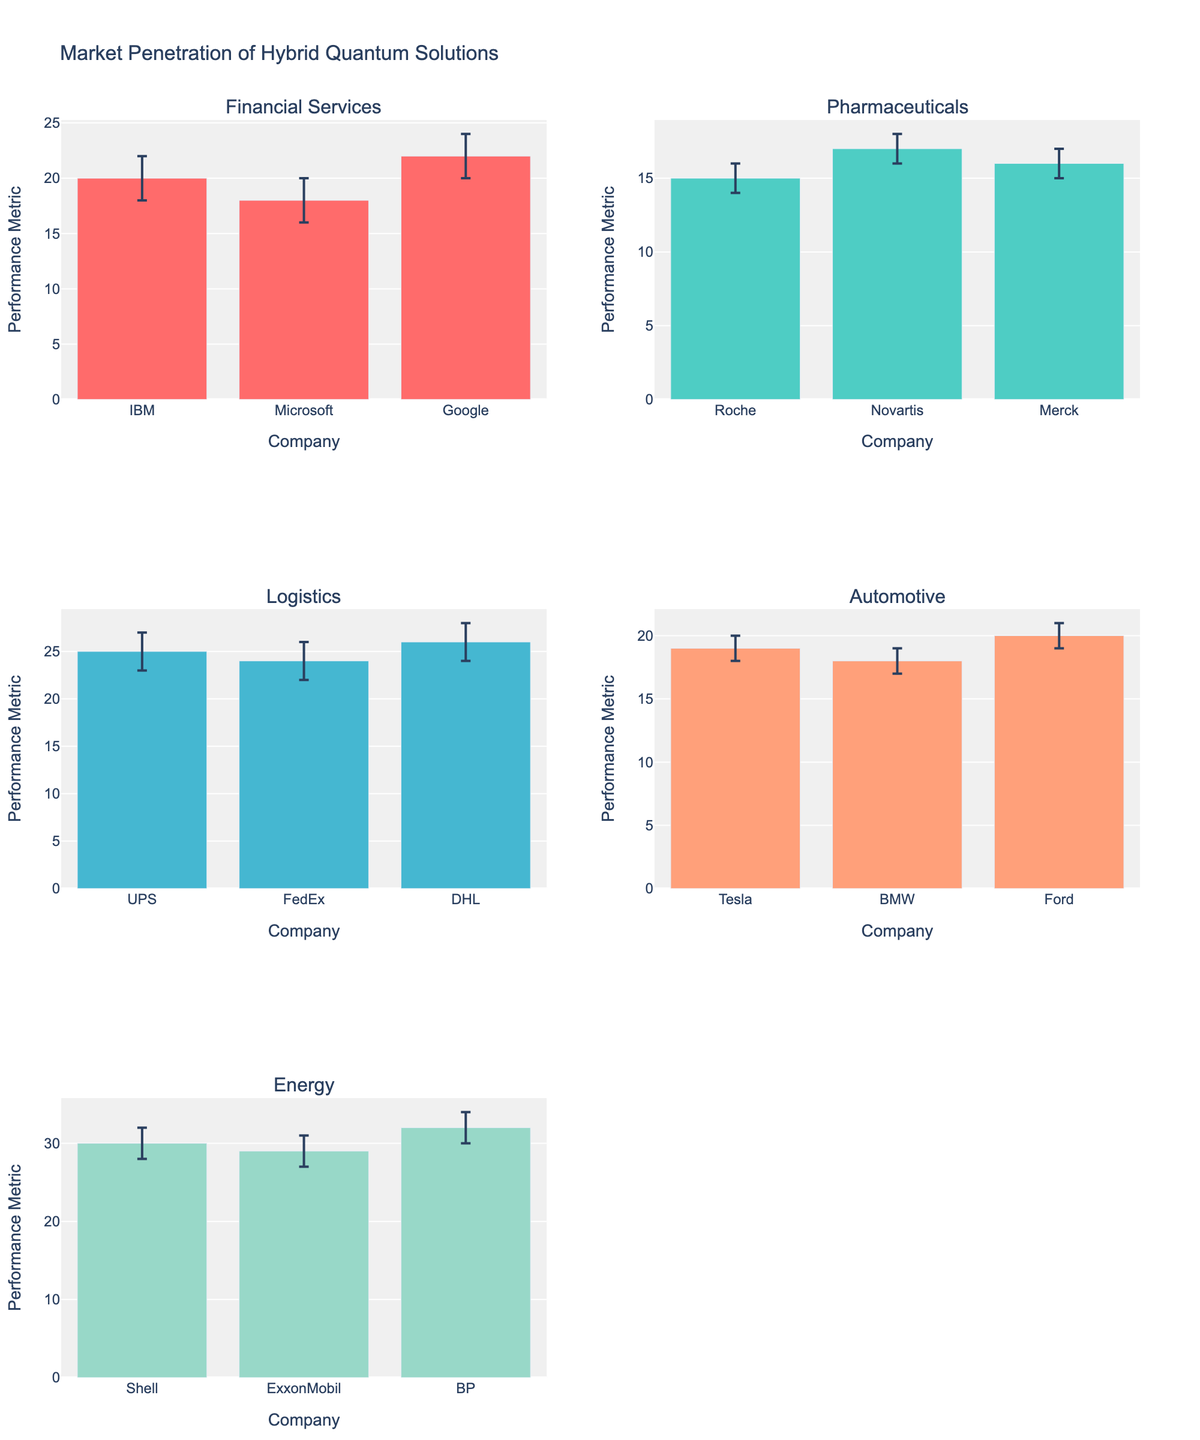how many companies are represented in the logistics segment? there are three companies listed within the logistics segment, which are ups, FedEx, and dhl.
Answer: 3 what is the difference between the highest and lowest performance metric in the financial services segment? the highest performance metric in the financial services segment is from Google at 22, and the lowest is from Microsoft at 18. the difference between the two is 22 - 18 = 4.
Answer: 4 which company in the energy segment has the largest error margin in their performance metric? to find the largest error margin, check the bounds. shell (32-28=4), exxonmobil (31-27=4), and bp (34-30=4). so exxonmobil and bp have tied for the largest error margin of 4.
Answer: bp, exxonmobil how does the performance metric of tesla compare to that of ford in the automotive segment? in the automotive segment, Tesla's performance metric is 19 while Ford's is 20. therefore, Ford's performance metric is 1 point higher than Tesla's.
Answer: Ford is higher by 1 which application segment has the highest average performance metric across all companies? calculate the average performance metric for each segment: financial services (20+18+22)/3 = 20, pharmaceuticals (15+17+16)/3 = 16, logistics (25+24+26)/3 = 25, automotive (19+18+20)/3 = 19, energy (30+29+32)/3 = 30. energy has the highest average performance metric (30).
Answer: energy in the pharmaceuticals segment, which company has the smallest upper error bound? roche, novartis, and merck have the following upper error bounds respectively: 16, 18, and 17. roche has the smallest upper error bound of 16.
Answer: roche how much more is the highest performance metric in the logistics segment compared to the lowest in the energy segment? the highest performance metric in the logistics segment is dhl at 26, and the lowest in the energy segment is exxonmobil at 29. 26 - 29 = -3; but because we're dealing with "more" it should be viewed consistently, hence exxonmobil is 3 more than dhl’s 26.
Answer: 3 which company has the widest error margin in the financial services segment? the error margins for IBM, Microsoft, and google are found by comparing their error bounds. IBM: (22-20) + (20-18) = 4, microsoft: (20 - 18) + (18 - 16) = 4, Google: (24 - 22) + (22 - 20) = 4. all companies in financial services have the same error margin of 4.
Answer: IBM, Microsoft, google 